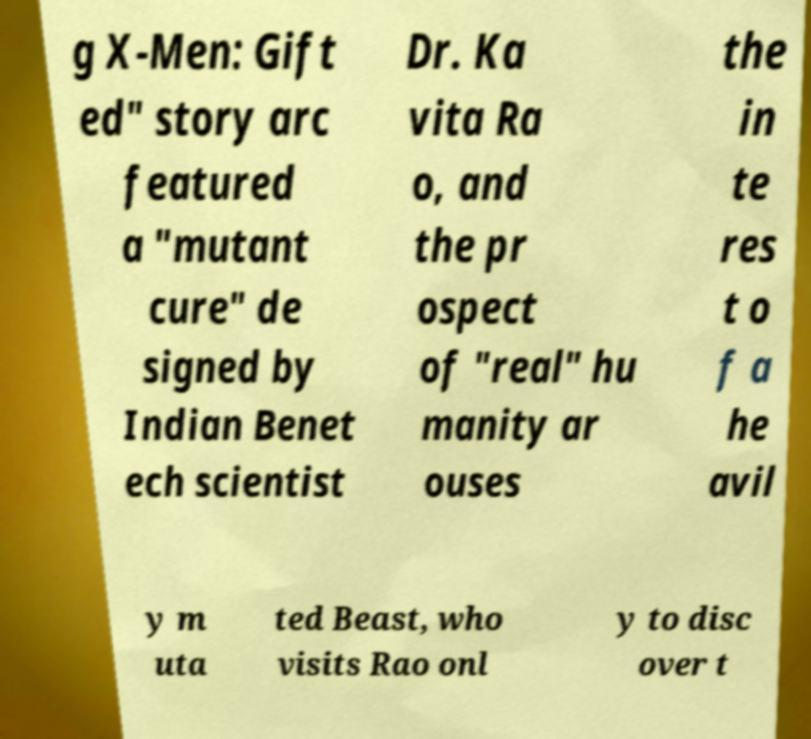Could you assist in decoding the text presented in this image and type it out clearly? g X-Men: Gift ed" story arc featured a "mutant cure" de signed by Indian Benet ech scientist Dr. Ka vita Ra o, and the pr ospect of "real" hu manity ar ouses the in te res t o f a he avil y m uta ted Beast, who visits Rao onl y to disc over t 